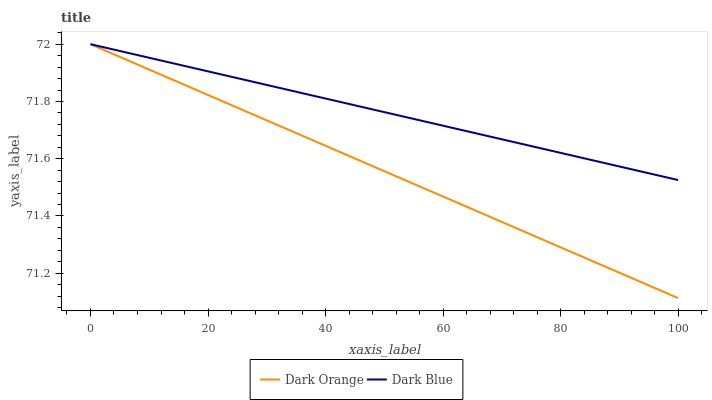Does Dark Orange have the minimum area under the curve?
Answer yes or no. Yes. Does Dark Blue have the maximum area under the curve?
Answer yes or no. Yes. Does Dark Blue have the minimum area under the curve?
Answer yes or no. No. Is Dark Blue the smoothest?
Answer yes or no. Yes. Is Dark Orange the roughest?
Answer yes or no. Yes. Is Dark Blue the roughest?
Answer yes or no. No. Does Dark Orange have the lowest value?
Answer yes or no. Yes. Does Dark Blue have the lowest value?
Answer yes or no. No. Does Dark Blue have the highest value?
Answer yes or no. Yes. Does Dark Orange intersect Dark Blue?
Answer yes or no. Yes. Is Dark Orange less than Dark Blue?
Answer yes or no. No. Is Dark Orange greater than Dark Blue?
Answer yes or no. No. 